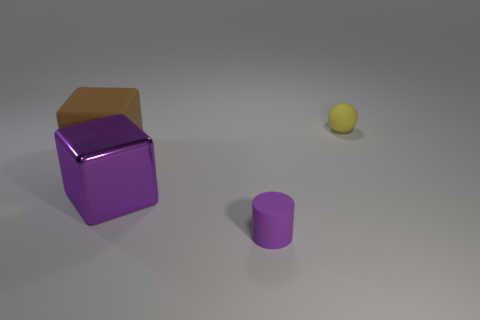Add 4 cyan matte balls. How many objects exist? 8 Subtract all cylinders. How many objects are left? 3 Subtract all purple blocks. Subtract all yellow matte things. How many objects are left? 2 Add 1 small yellow things. How many small yellow things are left? 2 Add 1 small blue matte cylinders. How many small blue matte cylinders exist? 1 Subtract 0 cyan cylinders. How many objects are left? 4 